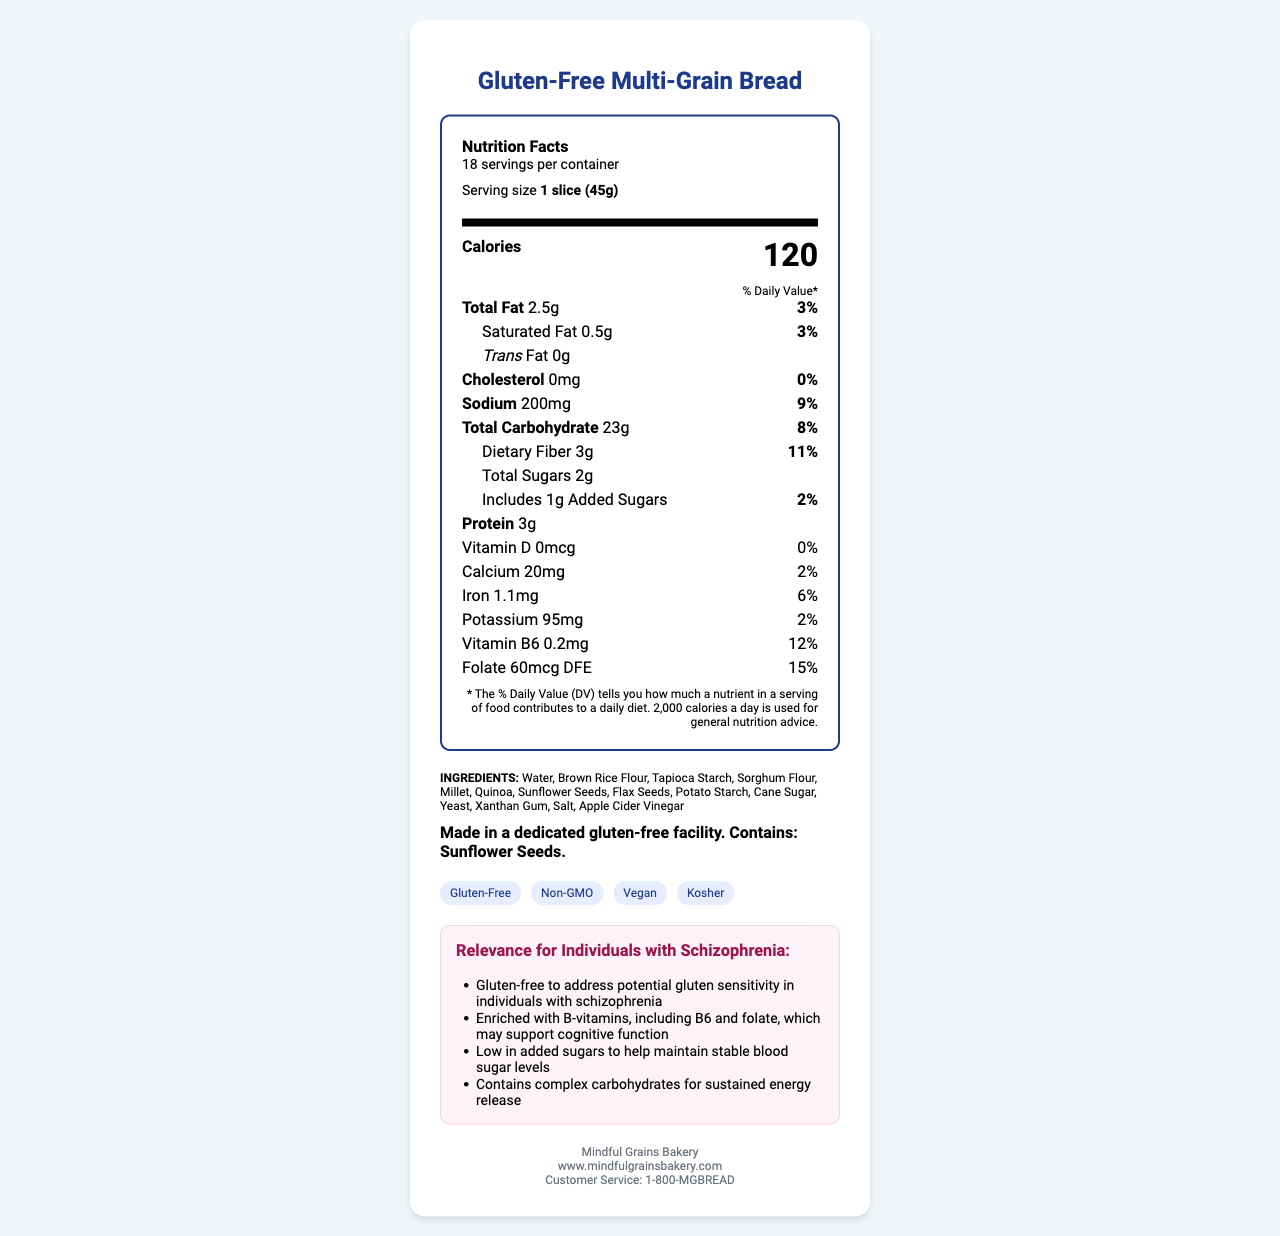what is the serving size of the Gluten-Free Multi-Grain Bread? The serving size is listed in the document as "1 slice (45g)."
Answer: 1 slice (45g) how many calories are there in one serving? The document states the calorie content as 120 in the bold "Calories" section.
Answer: 120 calories what is the amount of dietary fiber per serving? The amount of dietary fiber per serving is specified as 3g in the "Total Carbohydrate" section under "Dietary Fiber."
Answer: 3g how many servings are in one container of Gluten-Free Multi-Grain Bread? The document mentions there are 18 servings per container in the serving-info section.
Answer: 18 servings what type of allergens are present in this product? The allergen information is found in the allergen section, which specifies "Contains: Sunflower Seeds."
Answer: Sunflower Seeds what is the manufacturing facility's status regarding gluten? This information is included in the allergen section stating, "Made in a dedicated gluten-free facility."
Answer: Made in a dedicated gluten-free facility. how much added sugars are in one serving? The document lists 1g of added sugars under the "Total Carbohydrate" section.
Answer: 1g which vitamin has the highest daily value percentage in this product? The document states that folate has a 15% daily value, which is the highest among all the listed vitamins and minerals.
Answer: Folate which of the following health claims is not mentioned in the document for this product? A. Gluten-Free B. Organic C. Vegan D. Kosher The health claims section specifies "Gluten-Free", "Non-GMO", "Vegan", and "Kosher"; "Organic" is not mentioned.
Answer: B what is the daily value percentage of sodium for one serving? A. 3% B. 6% C. 9% D. 12% The daily value percentage for sodium is listed as 9% in the sodium section.
Answer: C does this product contain any trans fat? The document clearly indicates "0g" under the "Trans Fat" section.
Answer: No is this bread enriched with B-vitamins? The relevance section specifies that the product is enriched with B-vitamins, including B6 and folate.
Answer: Yes summarize the main attributes of the Gluten-Free Multi-Grain Bread. The document details the product's attributes, including its nutritional content, allergen information, vitamin enrichment, health claims, and relevance for individuals with schizophrenia, emphasizing its gluten-free nature and B-vitamin content.
Answer: Gluten-Free Multi-Grain Bread is a gluten-free product made in a dedicated facility, contains essential B-vitamins, low in added sugars, and offers a mix of complex carbohydrates for sustained energy. what is the source of 95mg potassium content in this product? The document provides the potassium amount but does not specify the exact sources within the ingredients list provided.
Answer: Cannot be determined 